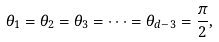<formula> <loc_0><loc_0><loc_500><loc_500>\theta _ { 1 } = \theta _ { 2 } = \theta _ { 3 } = \cdots = \theta _ { d - 3 } = \frac { \pi } { 2 } ,</formula> 